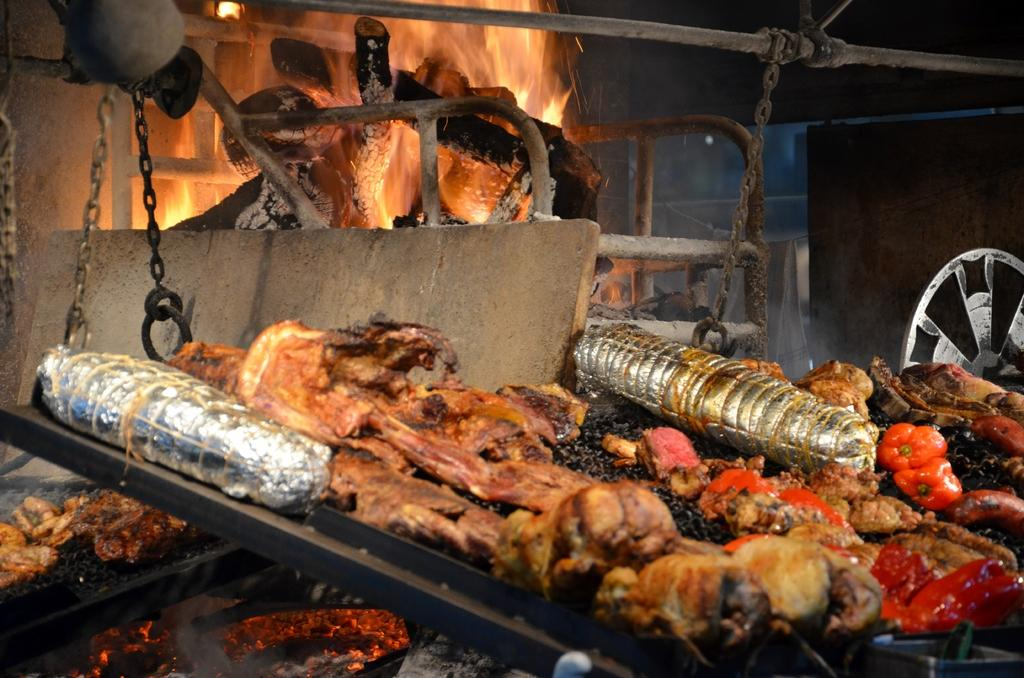What type of objects can be seen in the image? There are food items, a flame, coal, a metal chain, and a metal rod in the image. Can you describe the flame in the image? Yes, there is a flame in the image. What material is the chain made of? The chain in the image is made of metal. What is the purpose of the coal in the image? The coal is likely used as fuel for the flame. What type of loaf is being prepared by the laborer in the image? There is no laborer or loaf present in the image. What is the cause of the flame in the image? The cause of the flame in the image is not explicitly stated, but it may be fueled by the coal. 